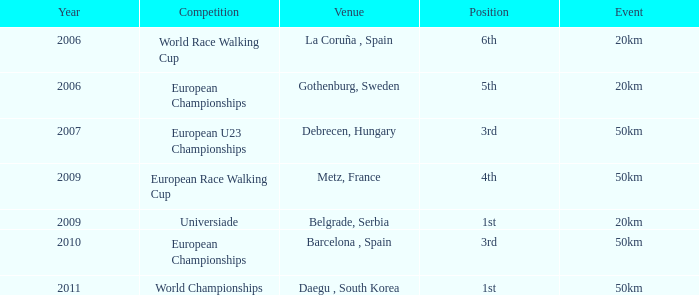Which Event has 5th Position in the European Championships Competition? 20km. 